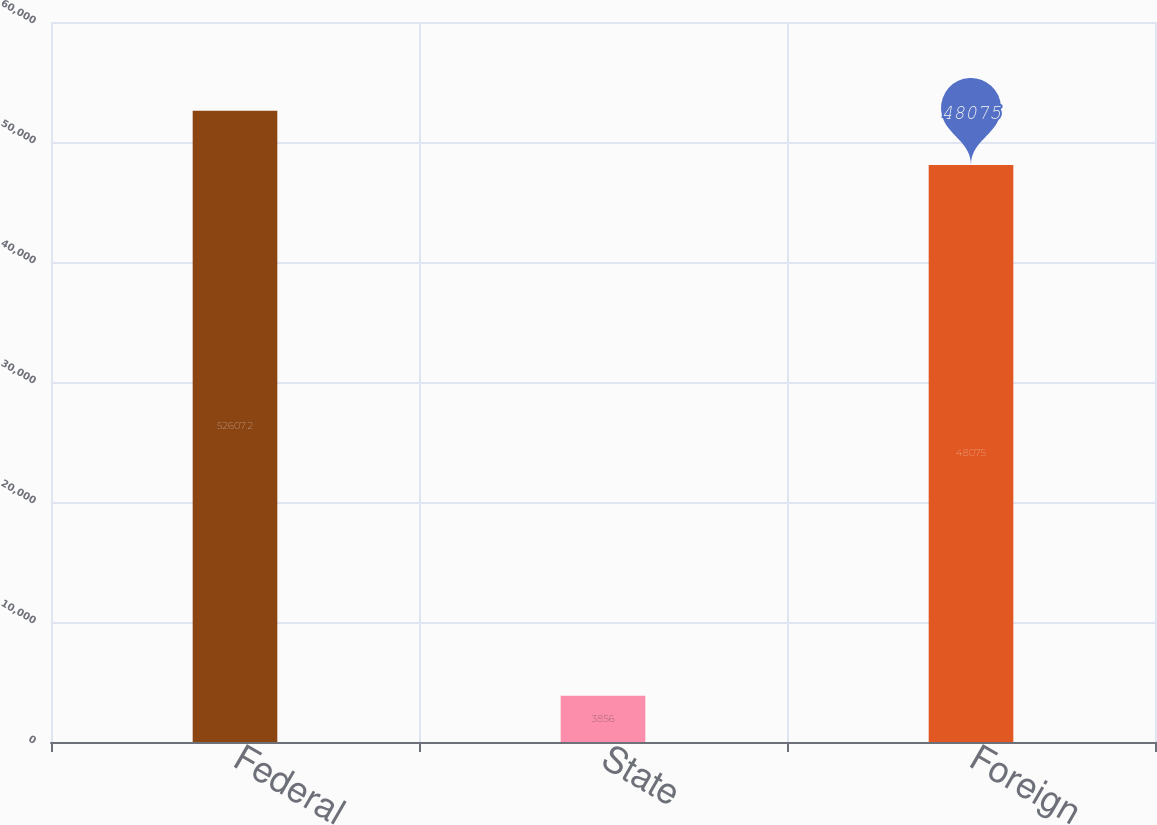Convert chart to OTSL. <chart><loc_0><loc_0><loc_500><loc_500><bar_chart><fcel>Federal<fcel>State<fcel>Foreign<nl><fcel>52607.2<fcel>3856<fcel>48075<nl></chart> 